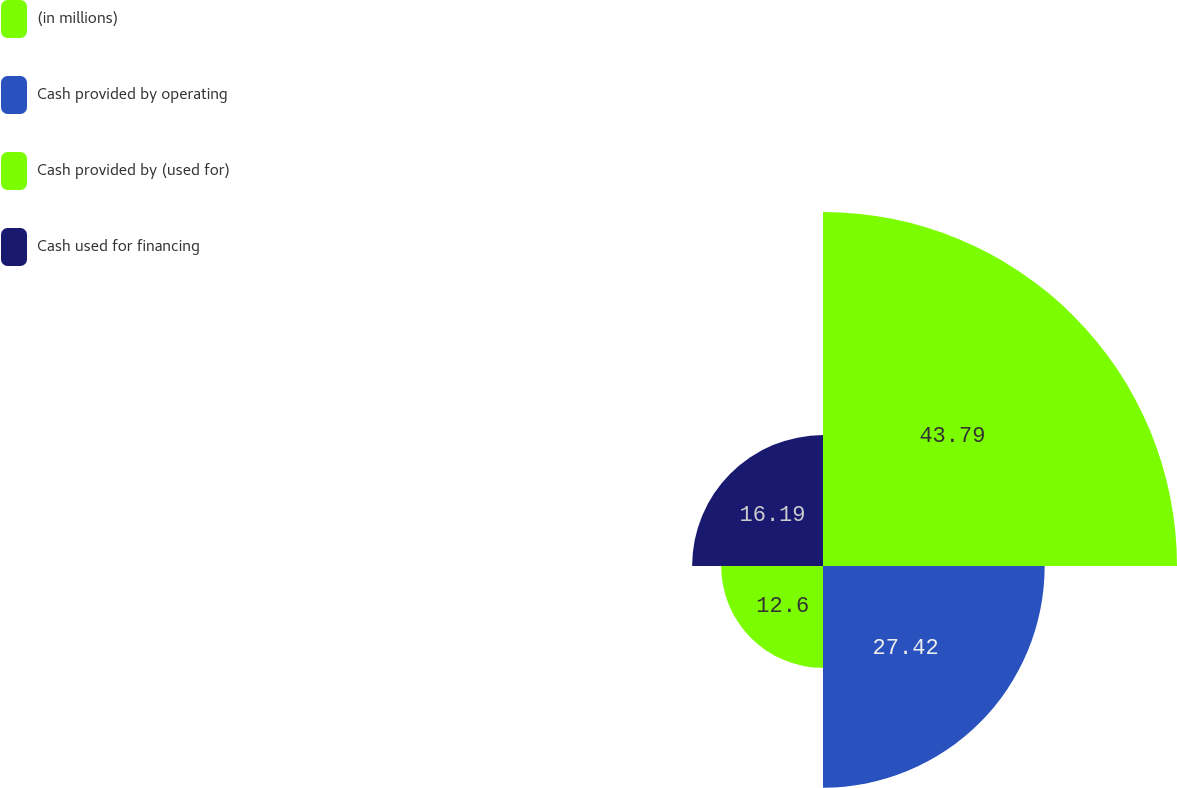<chart> <loc_0><loc_0><loc_500><loc_500><pie_chart><fcel>(in millions)<fcel>Cash provided by operating<fcel>Cash provided by (used for)<fcel>Cash used for financing<nl><fcel>43.79%<fcel>27.42%<fcel>12.6%<fcel>16.19%<nl></chart> 